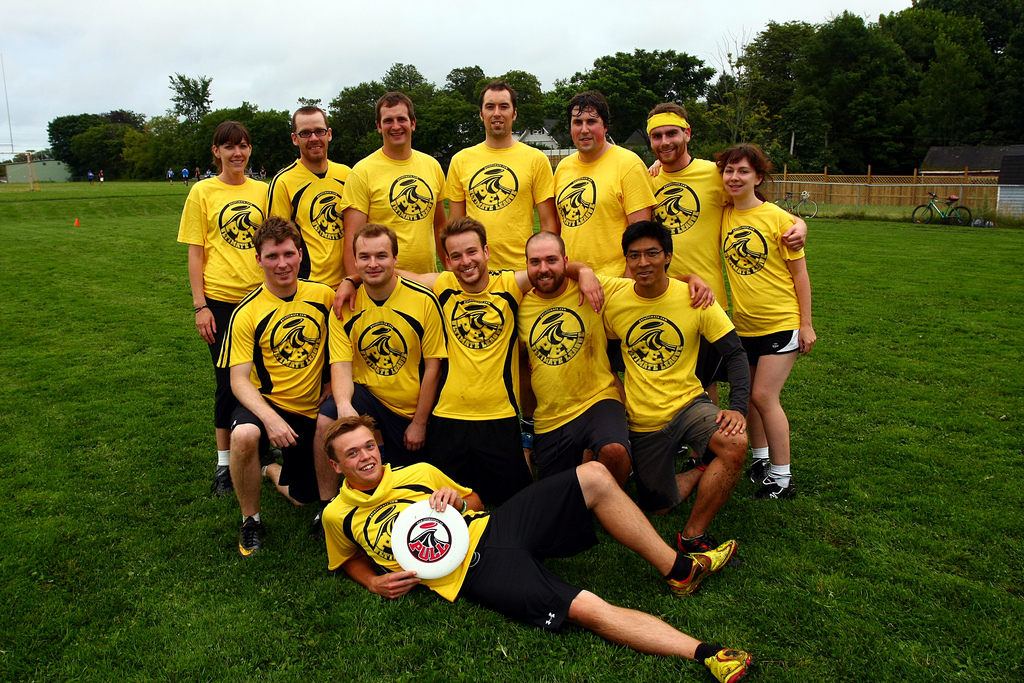What can you infer about the weather and time of the day in this photo? The photo has diffused lighting and the grass appears damp, suggesting overcast weather conditions, possibly after a rain shower. There are no shadows that indicate the time of day, but the light suggests it could be either late morning or early afternoon. Do you see any indicators that this event is competitive or casual? The team’s joyful expressions and the casual poses lend a relaxed atmosphere to the scene, which might imply that the event is more casual and friendly rather than highly competitive. However, matching team shirts can also indicate an organized event, which could involve some level of competition. 